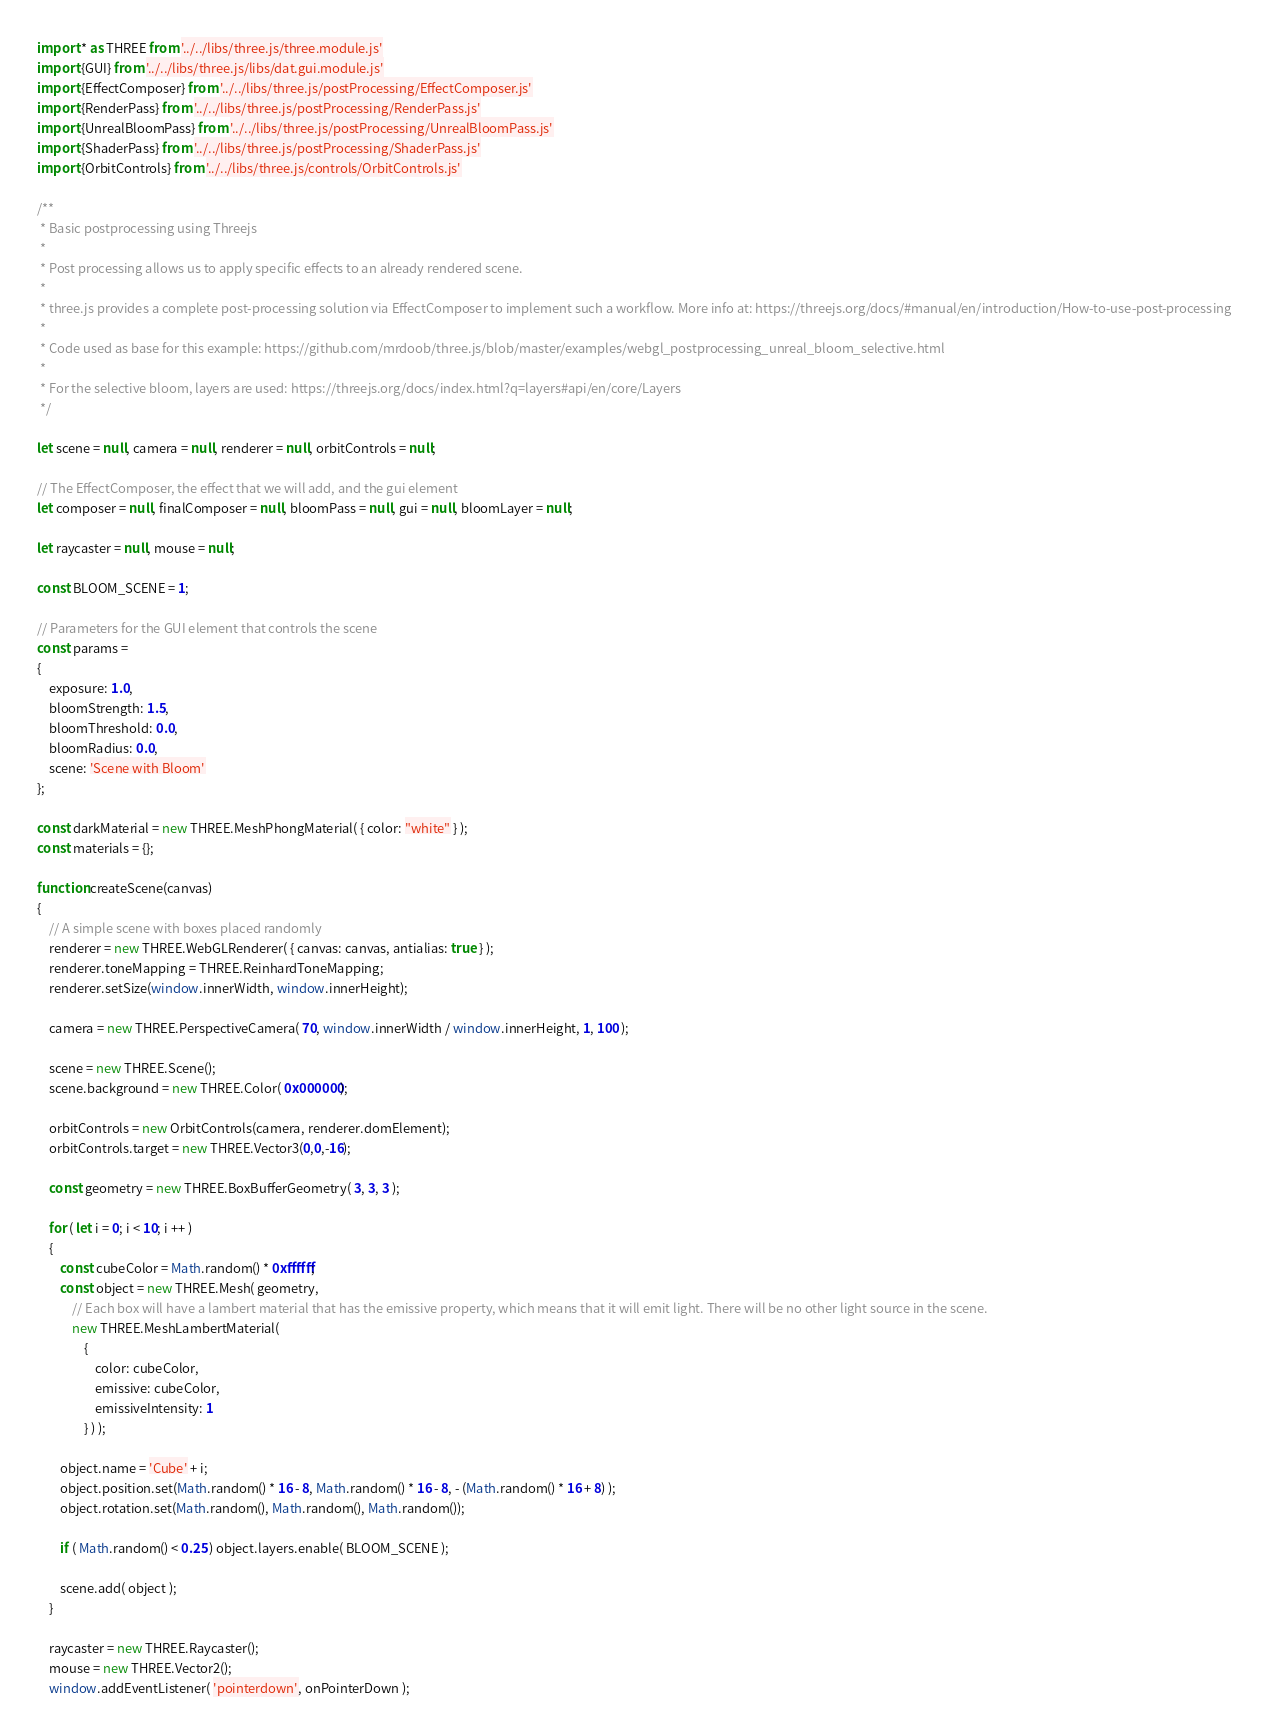Convert code to text. <code><loc_0><loc_0><loc_500><loc_500><_JavaScript_>import * as THREE from '../../libs/three.js/three.module.js'
import {GUI} from '../../libs/three.js/libs/dat.gui.module.js'
import {EffectComposer} from '../../libs/three.js/postProcessing/EffectComposer.js'
import {RenderPass} from '../../libs/three.js/postProcessing/RenderPass.js'
import {UnrealBloomPass} from '../../libs/three.js/postProcessing/UnrealBloomPass.js'
import {ShaderPass} from '../../libs/three.js/postProcessing/ShaderPass.js'
import {OrbitControls} from '../../libs/three.js/controls/OrbitControls.js'

/**
 * Basic postprocessing using Threejs
 *
 * Post processing allows us to apply specific effects to an already rendered scene.
 *
 * three.js provides a complete post-processing solution via EffectComposer to implement such a workflow. More info at: https://threejs.org/docs/#manual/en/introduction/How-to-use-post-processing
 * 
 * Code used as base for this example: https://github.com/mrdoob/three.js/blob/master/examples/webgl_postprocessing_unreal_bloom_selective.html
 * 
 * For the selective bloom, layers are used: https://threejs.org/docs/index.html?q=layers#api/en/core/Layers
 */

let scene = null, camera = null, renderer = null, orbitControls = null;

// The EffectComposer, the effect that we will add, and the gui element
let composer = null, finalComposer = null, bloomPass = null, gui = null, bloomLayer = null;

let raycaster = null, mouse = null;

const BLOOM_SCENE = 1;

// Parameters for the GUI element that controls the scene
const params =
{
    exposure: 1.0,
    bloomStrength: 1.5,
    bloomThreshold: 0.0,
    bloomRadius: 0.0,
    scene: 'Scene with Bloom'
};

const darkMaterial = new THREE.MeshPhongMaterial( { color: "white" } );
const materials = {};

function createScene(canvas)
{
    // A simple scene with boxes placed randomly
    renderer = new THREE.WebGLRenderer( { canvas: canvas, antialias: true } );
    renderer.toneMapping = THREE.ReinhardToneMapping;
    renderer.setSize(window.innerWidth, window.innerHeight);

    camera = new THREE.PerspectiveCamera( 70, window.innerWidth / window.innerHeight, 1, 100 );

    scene = new THREE.Scene();
    scene.background = new THREE.Color( 0x000000);

    orbitControls = new OrbitControls(camera, renderer.domElement);
    orbitControls.target = new THREE.Vector3(0,0,-16);

    const geometry = new THREE.BoxBufferGeometry( 3, 3, 3 );

    for ( let i = 0; i < 10; i ++ )
    {
        const cubeColor = Math.random() * 0xffffff;
        const object = new THREE.Mesh( geometry,
            // Each box will have a lambert material that has the emissive property, which means that it will emit light. There will be no other light source in the scene.
            new THREE.MeshLambertMaterial(
                {
                    color: cubeColor,
                    emissive: cubeColor,
                    emissiveIntensity: 1
                } ) );

        object.name = 'Cube' + i;
        object.position.set(Math.random() * 16 - 8, Math.random() * 16 - 8, - (Math.random() * 16 + 8) );
        object.rotation.set(Math.random(), Math.random(), Math.random());

        if ( Math.random() < 0.25 ) object.layers.enable( BLOOM_SCENE );

        scene.add( object );
    }

    raycaster = new THREE.Raycaster();
    mouse = new THREE.Vector2();
    window.addEventListener( 'pointerdown', onPointerDown );
</code> 